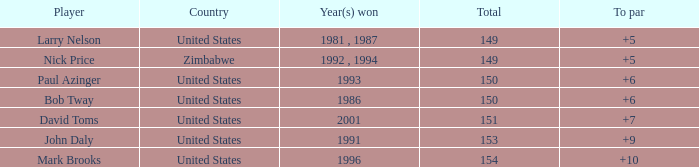How many to pars were won in 1993? 1.0. 